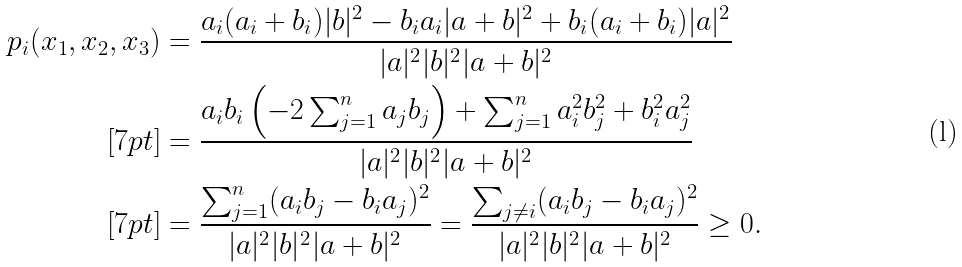Convert formula to latex. <formula><loc_0><loc_0><loc_500><loc_500>p _ { i } ( x _ { 1 } , x _ { 2 } , x _ { 3 } ) & = \frac { a _ { i } ( a _ { i } + b _ { i } ) | b | ^ { 2 } - b _ { i } a _ { i } | a + b | ^ { 2 } + b _ { i } ( a _ { i } + b _ { i } ) | a | ^ { 2 } } { | a | ^ { 2 } | b | ^ { 2 } | a + b | ^ { 2 } } \\ [ 7 p t ] & = \frac { a _ { i } b _ { i } \left ( - 2 \sum _ { j = 1 } ^ { n } a _ { j } b _ { j } \right ) + \sum _ { j = 1 } ^ { n } a _ { i } ^ { 2 } b _ { j } ^ { 2 } + b _ { i } ^ { 2 } a _ { j } ^ { 2 } } { | a | ^ { 2 } | b | ^ { 2 } | a + b | ^ { 2 } } \\ [ 7 p t ] & = \frac { \sum _ { j = 1 } ^ { n } ( a _ { i } b _ { j } - b _ { i } a _ { j } ) ^ { 2 } } { | a | ^ { 2 } | b | ^ { 2 } | a + b | ^ { 2 } } = \frac { \sum _ { j \neq i } ( a _ { i } b _ { j } - b _ { i } a _ { j } ) ^ { 2 } } { | a | ^ { 2 } | b | ^ { 2 } | a + b | ^ { 2 } } \geq 0 .</formula> 